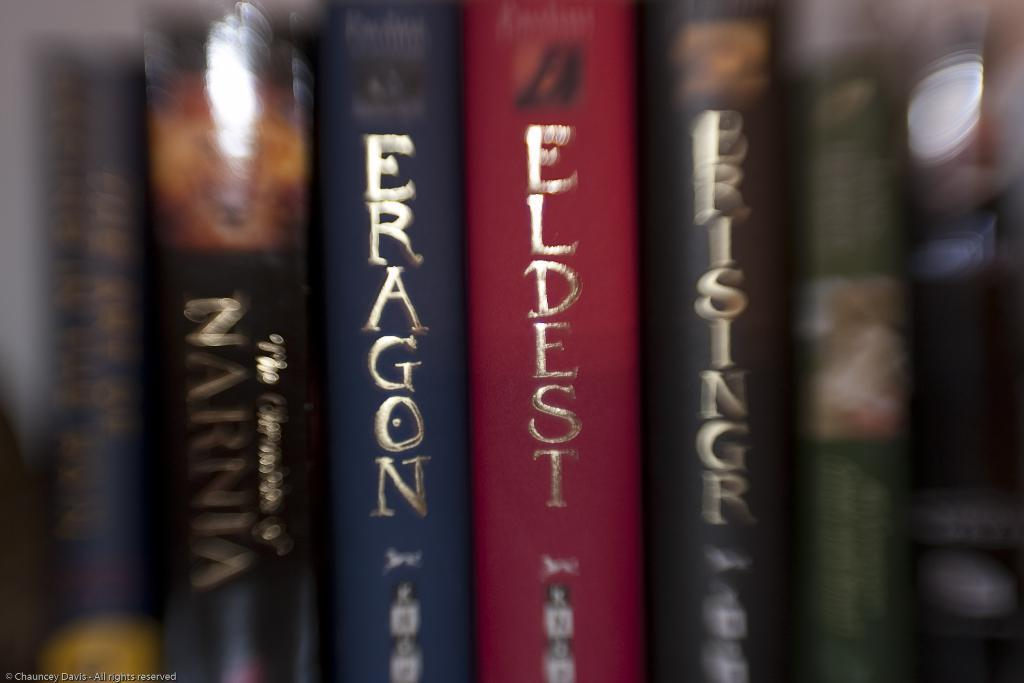<image>
Render a clear and concise summary of the photo. A red book with the title of Eldest is in the center of other lined up books. 